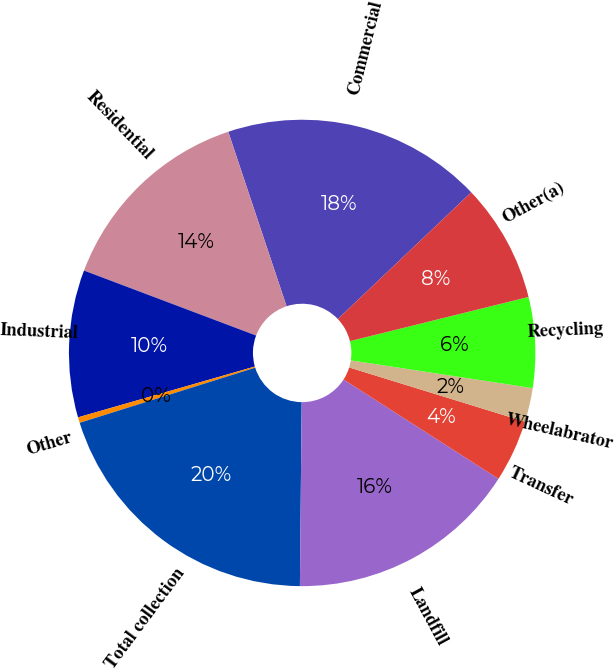<chart> <loc_0><loc_0><loc_500><loc_500><pie_chart><fcel>Commercial<fcel>Residential<fcel>Industrial<fcel>Other<fcel>Total collection<fcel>Landfill<fcel>Transfer<fcel>Wheelabrator<fcel>Recycling<fcel>Other(a)<nl><fcel>18.04%<fcel>14.12%<fcel>10.2%<fcel>0.39%<fcel>20.0%<fcel>16.08%<fcel>4.31%<fcel>2.35%<fcel>6.27%<fcel>8.23%<nl></chart> 